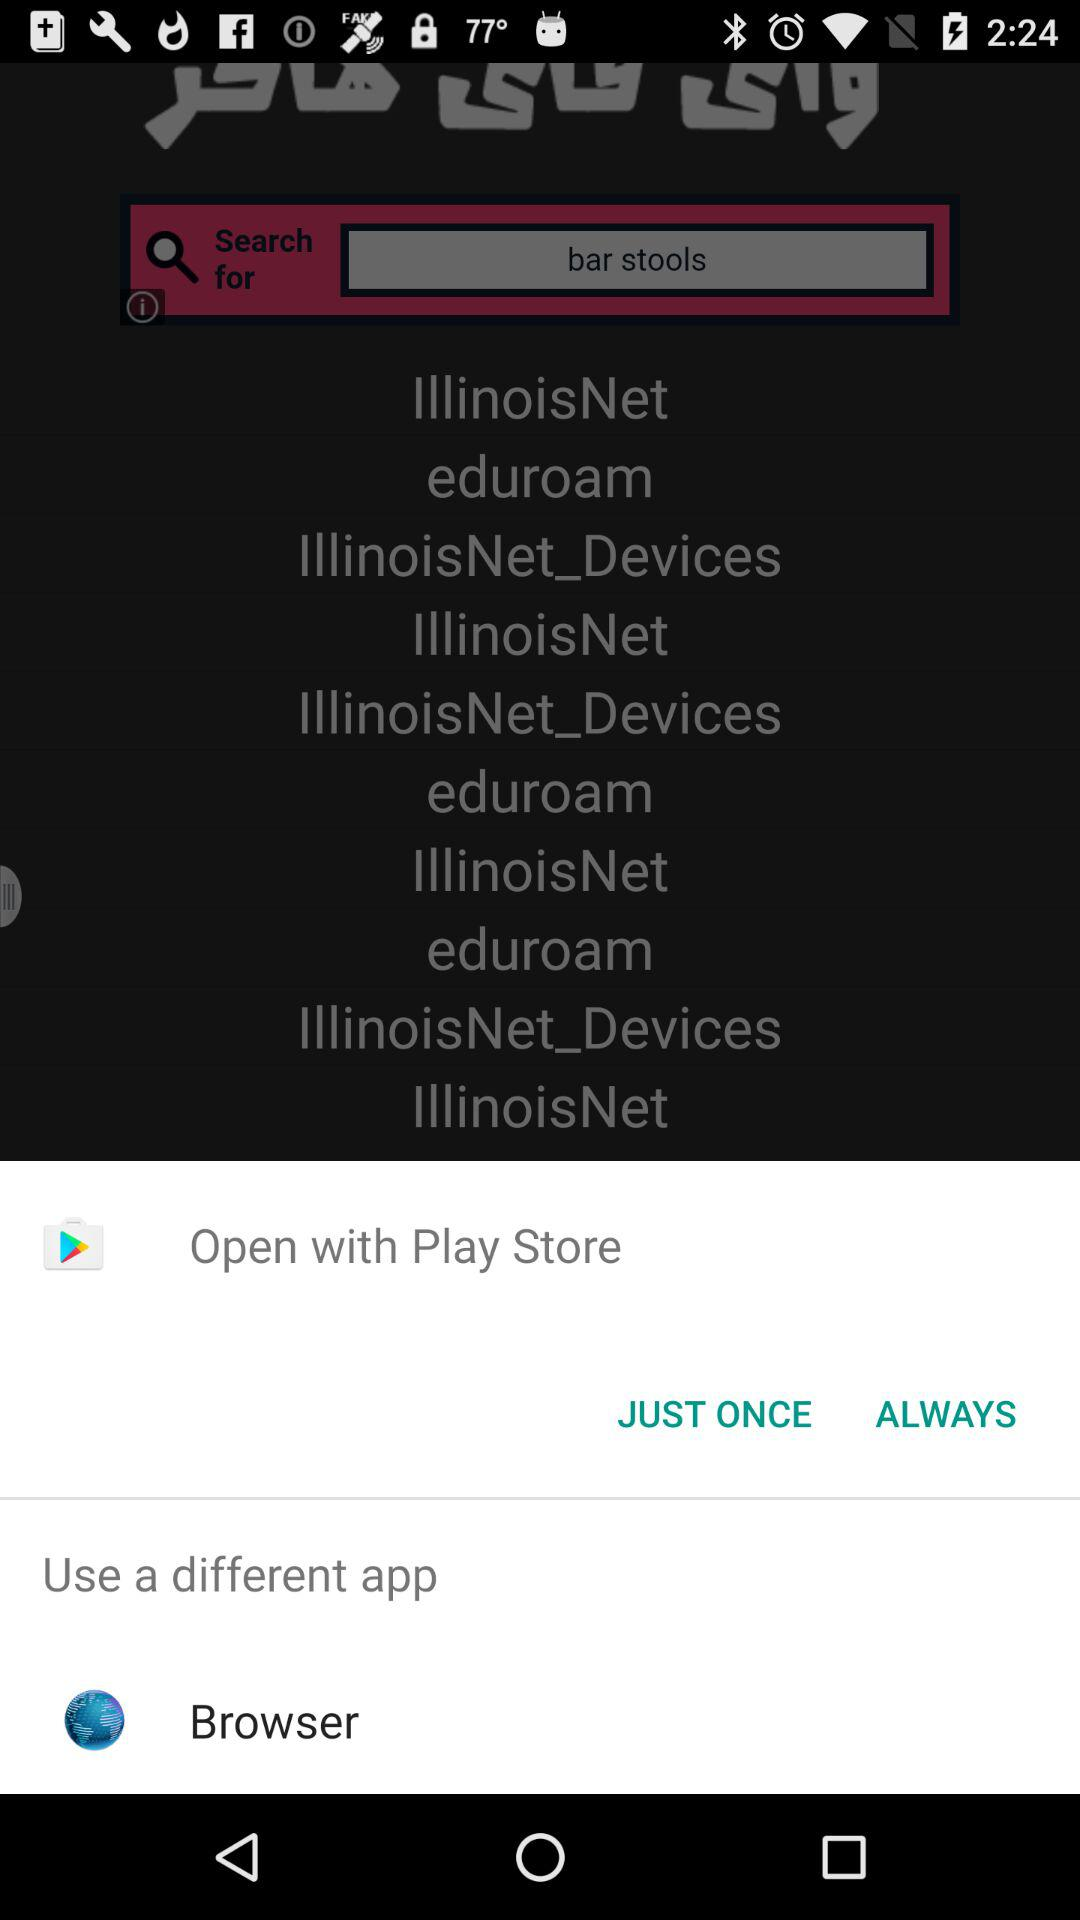How many IllinoisNet networks are available to connect to?
Answer the question using a single word or phrase. 4 